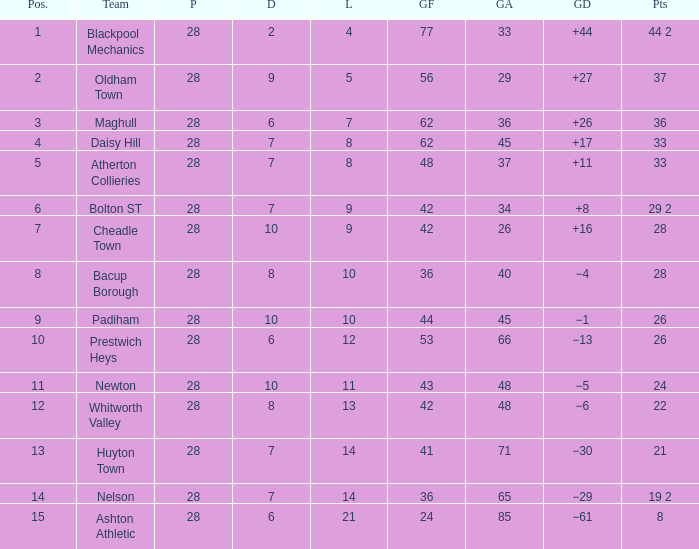For entries with fewer than 28 played, with 45 goals against and points 1 of 33, what is the average drawn? None. Could you parse the entire table as a dict? {'header': ['Pos.', 'Team', 'P', 'D', 'L', 'GF', 'GA', 'GD', 'Pts'], 'rows': [['1', 'Blackpool Mechanics', '28', '2', '4', '77', '33', '+44', '44 2'], ['2', 'Oldham Town', '28', '9', '5', '56', '29', '+27', '37'], ['3', 'Maghull', '28', '6', '7', '62', '36', '+26', '36'], ['4', 'Daisy Hill', '28', '7', '8', '62', '45', '+17', '33'], ['5', 'Atherton Collieries', '28', '7', '8', '48', '37', '+11', '33'], ['6', 'Bolton ST', '28', '7', '9', '42', '34', '+8', '29 2'], ['7', 'Cheadle Town', '28', '10', '9', '42', '26', '+16', '28'], ['8', 'Bacup Borough', '28', '8', '10', '36', '40', '−4', '28'], ['9', 'Padiham', '28', '10', '10', '44', '45', '−1', '26'], ['10', 'Prestwich Heys', '28', '6', '12', '53', '66', '−13', '26'], ['11', 'Newton', '28', '10', '11', '43', '48', '−5', '24'], ['12', 'Whitworth Valley', '28', '8', '13', '42', '48', '−6', '22'], ['13', 'Huyton Town', '28', '7', '14', '41', '71', '−30', '21'], ['14', 'Nelson', '28', '7', '14', '36', '65', '−29', '19 2'], ['15', 'Ashton Athletic', '28', '6', '21', '24', '85', '−61', '8']]} 